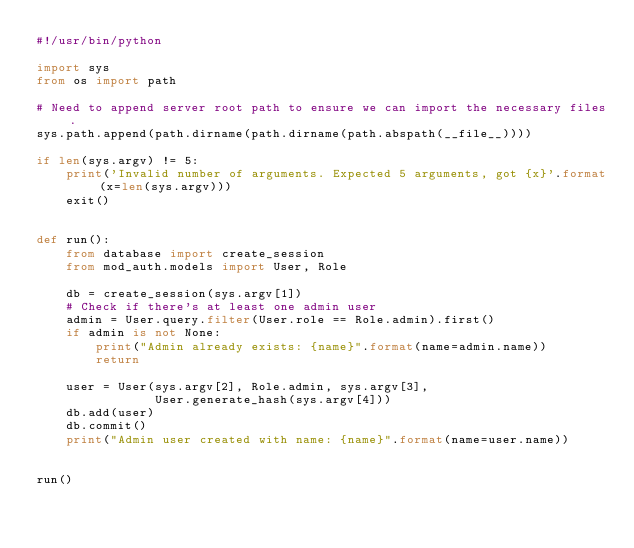<code> <loc_0><loc_0><loc_500><loc_500><_Python_>#!/usr/bin/python

import sys
from os import path

# Need to append server root path to ensure we can import the necessary files.
sys.path.append(path.dirname(path.dirname(path.abspath(__file__))))

if len(sys.argv) != 5:
    print('Invalid number of arguments. Expected 5 arguments, got {x}'.format(x=len(sys.argv)))
    exit()


def run():
    from database import create_session
    from mod_auth.models import User, Role

    db = create_session(sys.argv[1])
    # Check if there's at least one admin user
    admin = User.query.filter(User.role == Role.admin).first()
    if admin is not None:
        print("Admin already exists: {name}".format(name=admin.name))
        return

    user = User(sys.argv[2], Role.admin, sys.argv[3],
                User.generate_hash(sys.argv[4]))
    db.add(user)
    db.commit()
    print("Admin user created with name: {name}".format(name=user.name))


run()
</code> 